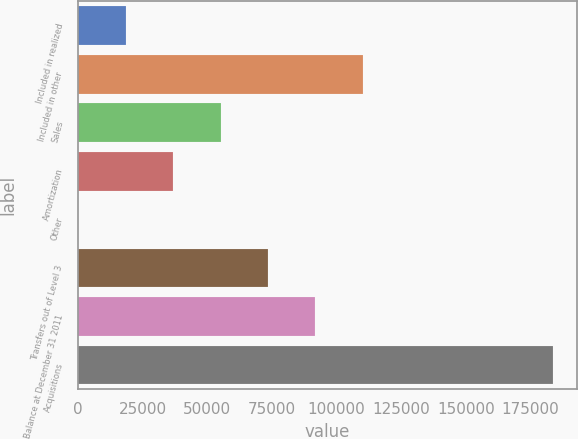<chart> <loc_0><loc_0><loc_500><loc_500><bar_chart><fcel>Included in realized<fcel>Included in other<fcel>Sales<fcel>Amortization<fcel>Other<fcel>Transfers out of Level 3<fcel>Balance at December 31 2011<fcel>Acquisitions<nl><fcel>18369.8<fcel>110207<fcel>55104.5<fcel>36737.1<fcel>2.39<fcel>73471.8<fcel>91839.2<fcel>183676<nl></chart> 